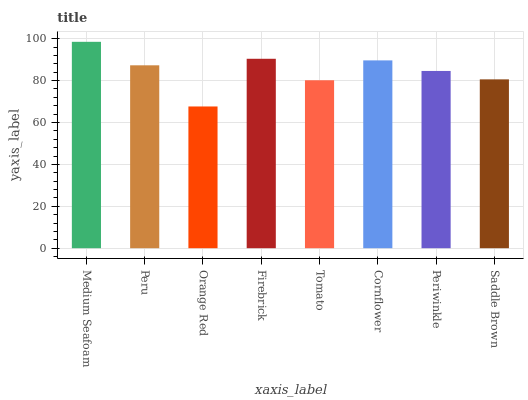Is Orange Red the minimum?
Answer yes or no. Yes. Is Medium Seafoam the maximum?
Answer yes or no. Yes. Is Peru the minimum?
Answer yes or no. No. Is Peru the maximum?
Answer yes or no. No. Is Medium Seafoam greater than Peru?
Answer yes or no. Yes. Is Peru less than Medium Seafoam?
Answer yes or no. Yes. Is Peru greater than Medium Seafoam?
Answer yes or no. No. Is Medium Seafoam less than Peru?
Answer yes or no. No. Is Peru the high median?
Answer yes or no. Yes. Is Periwinkle the low median?
Answer yes or no. Yes. Is Saddle Brown the high median?
Answer yes or no. No. Is Medium Seafoam the low median?
Answer yes or no. No. 